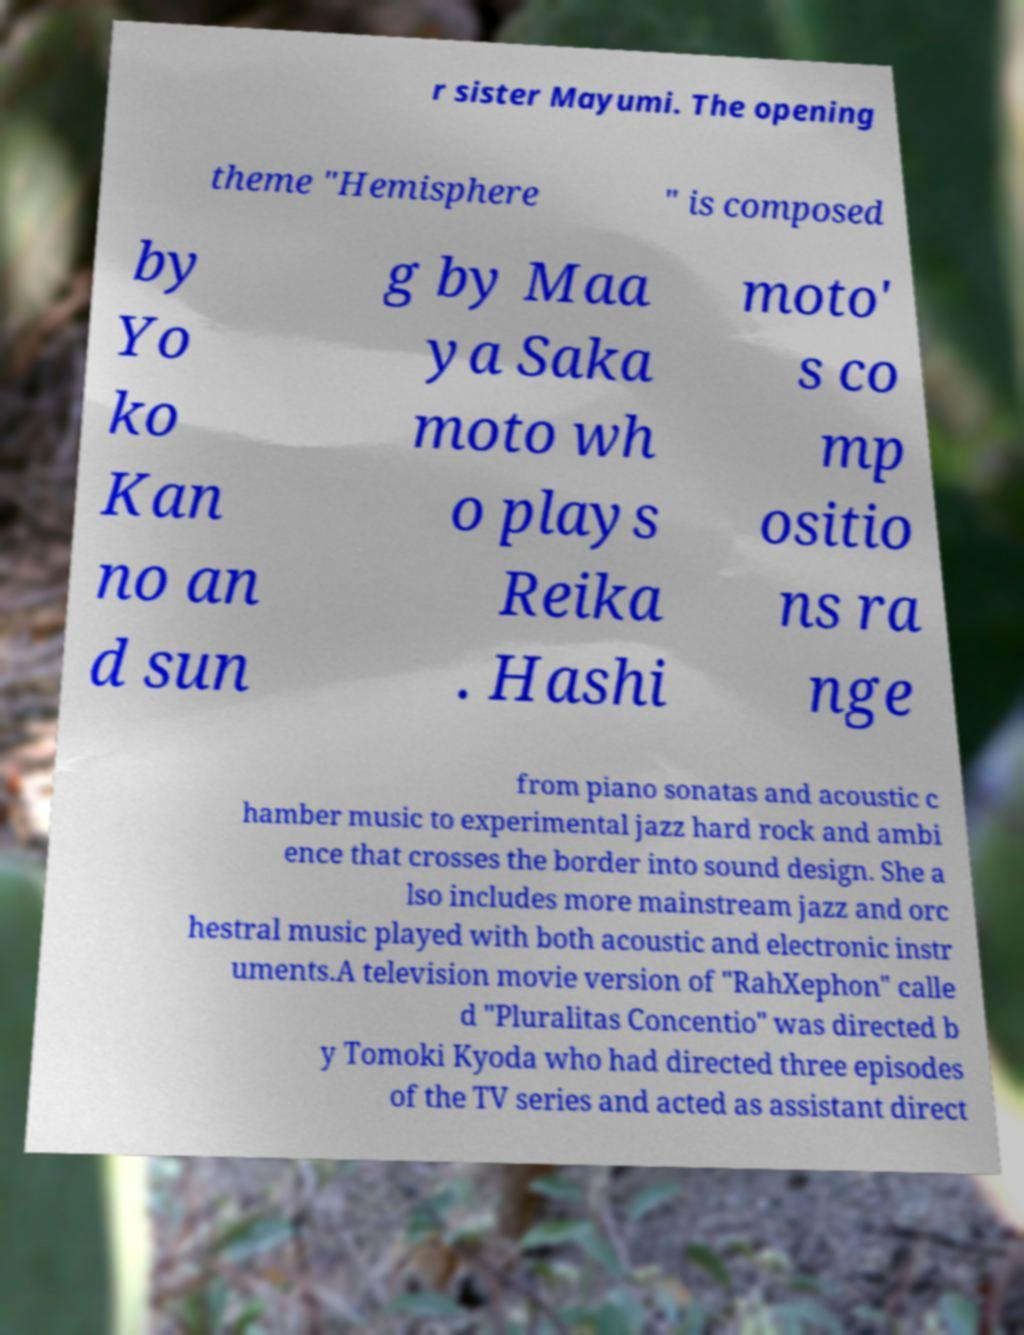I need the written content from this picture converted into text. Can you do that? r sister Mayumi. The opening theme "Hemisphere " is composed by Yo ko Kan no an d sun g by Maa ya Saka moto wh o plays Reika . Hashi moto' s co mp ositio ns ra nge from piano sonatas and acoustic c hamber music to experimental jazz hard rock and ambi ence that crosses the border into sound design. She a lso includes more mainstream jazz and orc hestral music played with both acoustic and electronic instr uments.A television movie version of "RahXephon" calle d "Pluralitas Concentio" was directed b y Tomoki Kyoda who had directed three episodes of the TV series and acted as assistant direct 